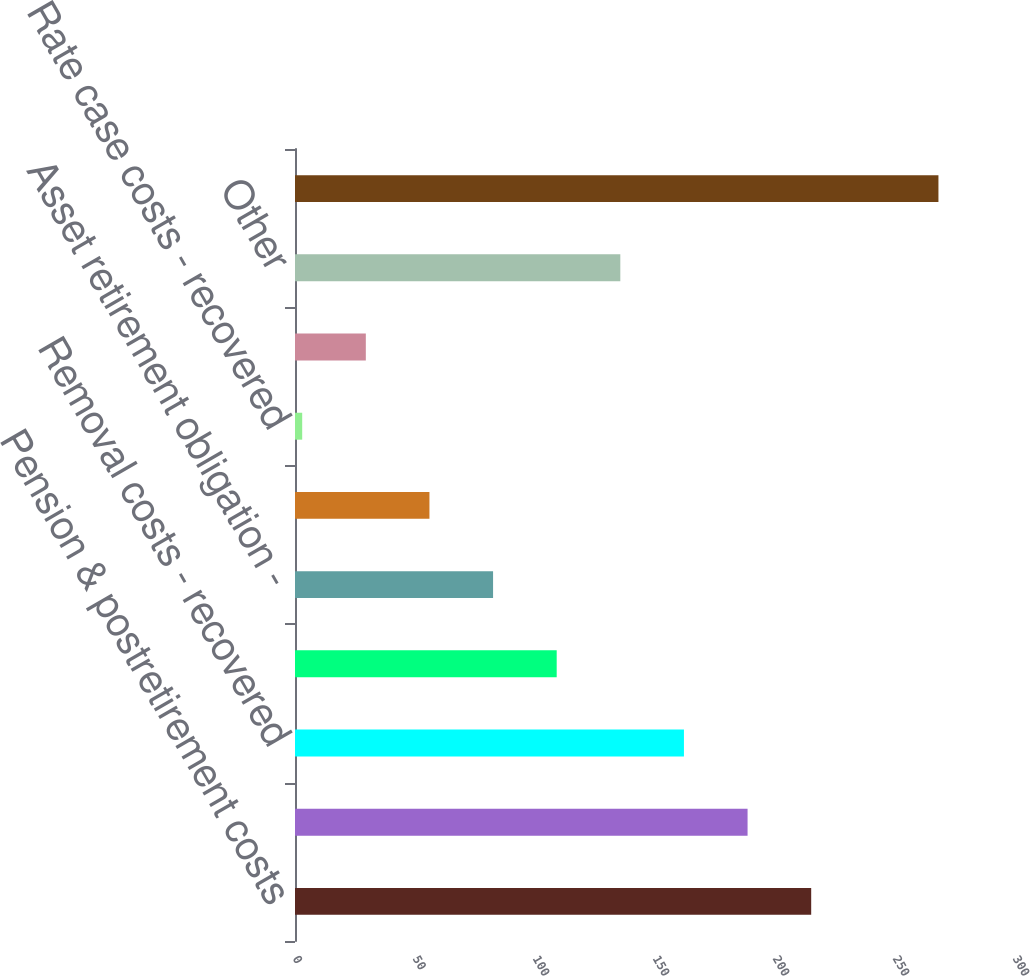<chart> <loc_0><loc_0><loc_500><loc_500><bar_chart><fcel>Pension & postretirement costs<fcel>Storm damage costs including<fcel>Removal costs - recovered<fcel>Retail rate deferrals -<fcel>Asset retirement obligation -<fcel>Unamortized loss on reacquired<fcel>Rate case costs - recovered<fcel>Michoud plant maintenance -<fcel>Other<fcel>Entergy New Orleans Total<nl><fcel>215.08<fcel>188.57<fcel>162.06<fcel>109.04<fcel>82.53<fcel>56.02<fcel>3<fcel>29.51<fcel>135.55<fcel>268.1<nl></chart> 